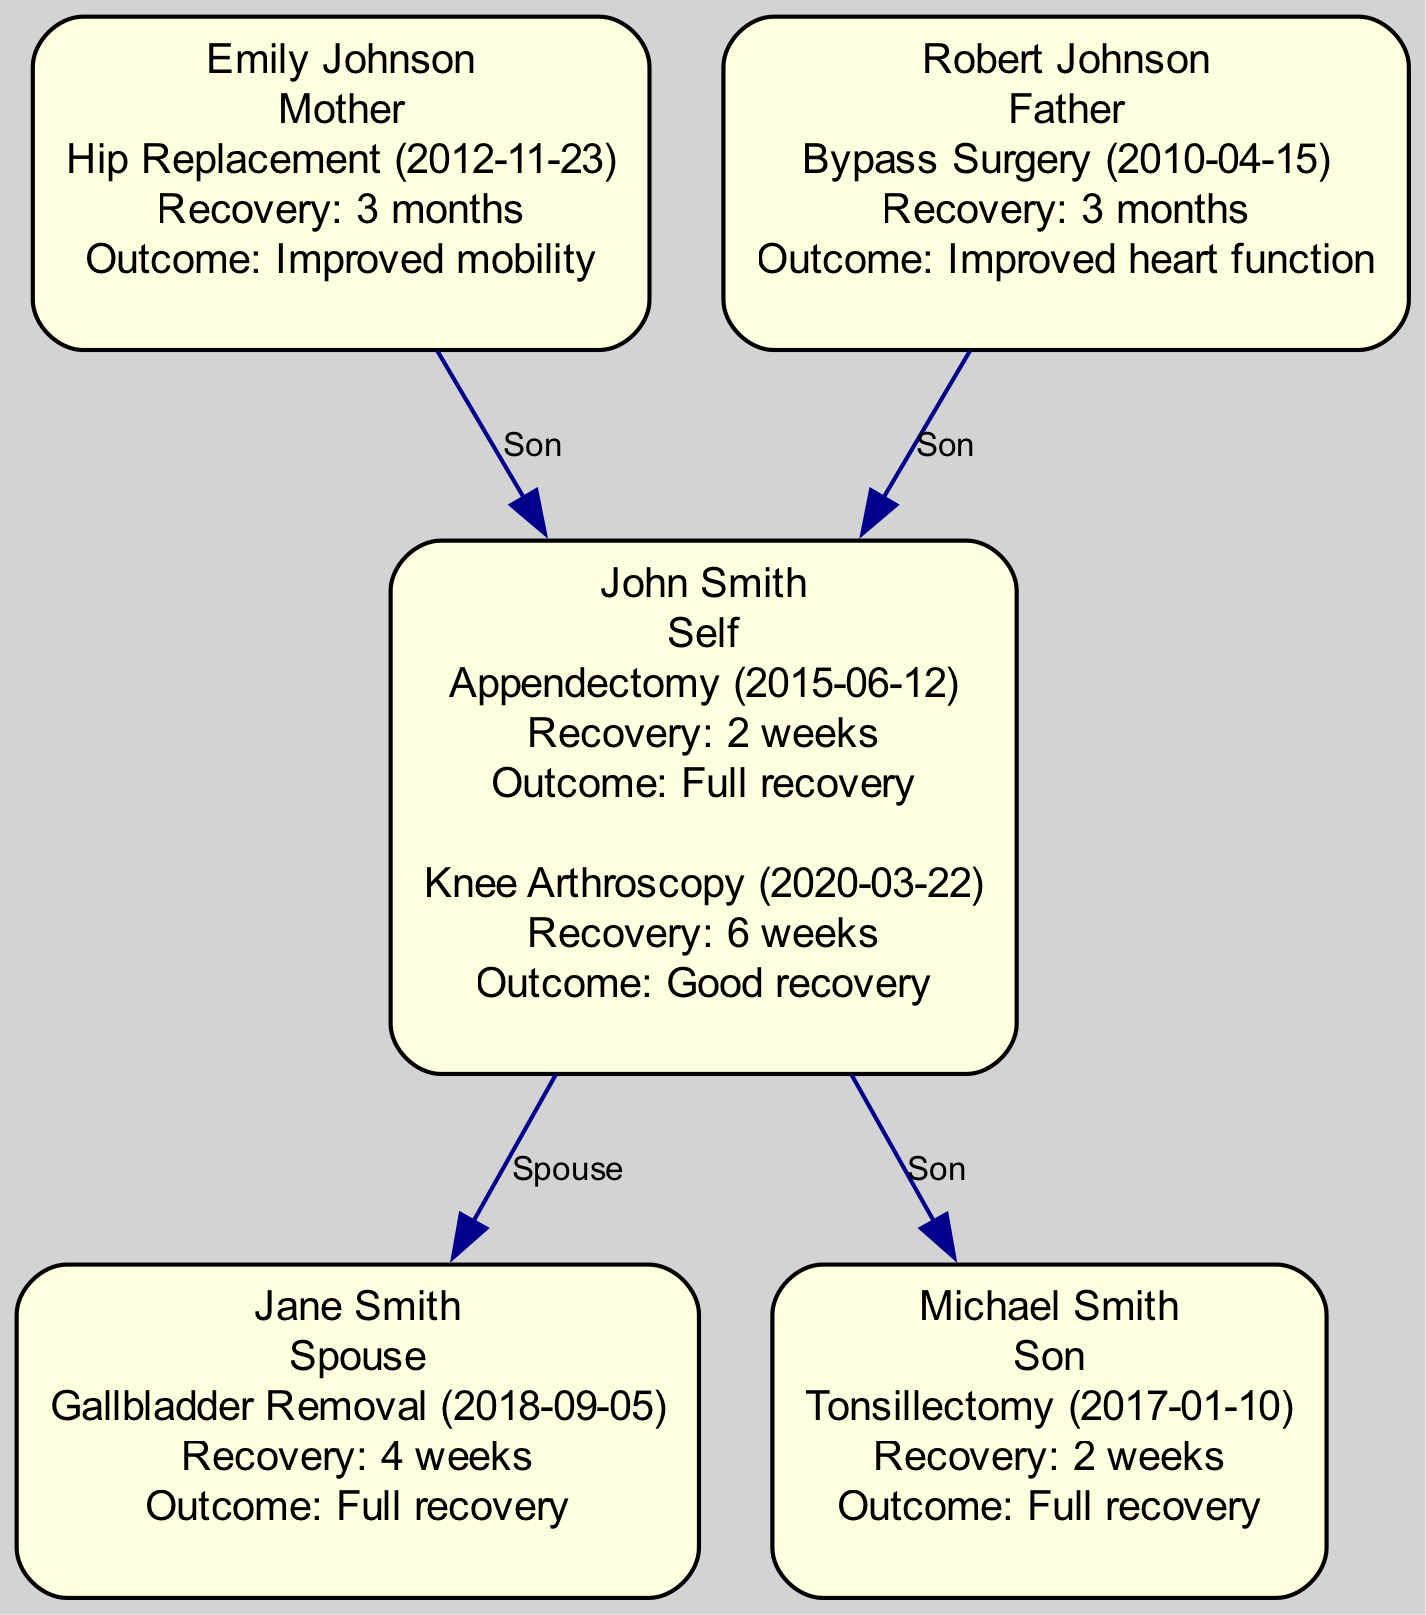What types of surgeries has John Smith undergone? John Smith has undergone two types of surgeries: Appendectomy on 2015-06-12 and Knee Arthroscopy on 2020-03-22.
Answer: Appendectomy, Knee Arthroscopy How long did it take for Emily Johnson to recover from her surgery? Emily Johnson had a Hip Replacement surgery on 2012-11-23, which had a recovery time of 3 months.
Answer: 3 months What is the relationship of Michael Smith to John Smith? Michael Smith is listed as John Smith's son in the family tree, indicating a direct parent-child relationship.
Answer: Son Which family member underwent a Gallbladder Removal surgery? Since Jane Smith is the only family member mentioned in the diagram who underwent the Gallbladder Removal surgery on 2018-09-05, she is the answer.
Answer: Jane Smith What was the outcome of Robert Johnson's surgery? Robert Johnson had Bypass Surgery on 2010-04-15, and the outcome was Improved heart function, as stated in the diagram.
Answer: Improved heart function How many members in the family tree had surgeries with a recovery time of 2 weeks? Both John Smith (Appendectomy and Knee Arthroscopy) and Michael Smith (Tonsillectomy) had surgeries with a recovery time of 2 weeks; thus, the count is 2.
Answer: 2 What surgery did Jane Smith have, and when? Jane Smith underwent Gallbladder Removal surgery on 2018-09-05, as indicated in the documentation of her surgeries.
Answer: Gallbladder Removal on 2018-09-05 Which family member experienced a recovery time greater than 4 weeks? Emily Johnson and Robert Johnson both experienced recovery times greater than 4 weeks, specifically 3 months each for their respective surgeries.
Answer: Emily Johnson, Robert Johnson Who is listed as the spouse of John Smith? Jane Smith is identified as the spouse of John Smith in the family tree, denoting their marital relationship.
Answer: Jane Smith 